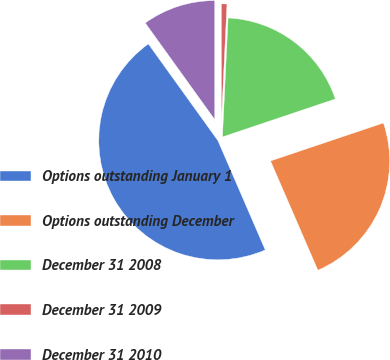Convert chart. <chart><loc_0><loc_0><loc_500><loc_500><pie_chart><fcel>Options outstanding January 1<fcel>Options outstanding December<fcel>December 31 2008<fcel>December 31 2009<fcel>December 31 2010<nl><fcel>46.58%<fcel>23.66%<fcel>19.08%<fcel>0.76%<fcel>9.92%<nl></chart> 